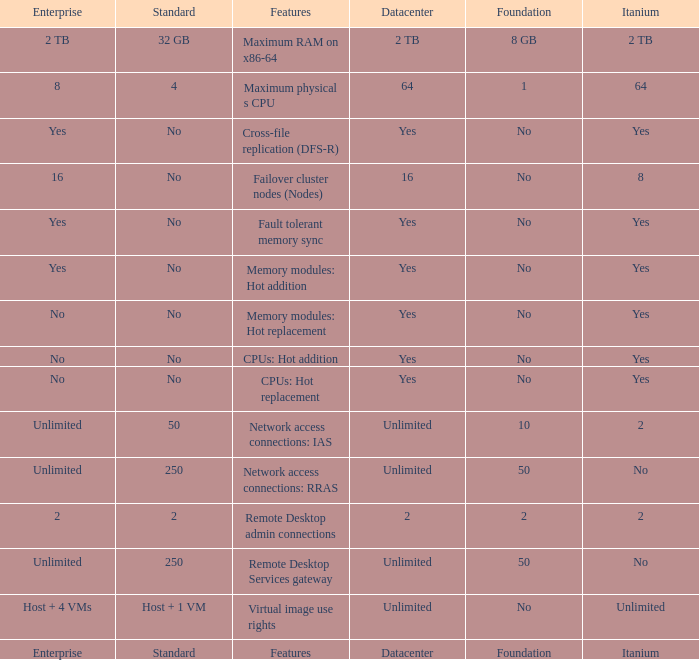Which Foundation has an Enterprise of 2? 2.0. 